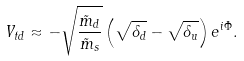Convert formula to latex. <formula><loc_0><loc_0><loc_500><loc_500>V _ { t d } \approx - \sqrt { \frac { \tilde { m } _ { d } } { \tilde { m } _ { s } } } \left ( \sqrt { \delta _ { d } } - \sqrt { \delta _ { u } } \right ) e ^ { i \Phi } .</formula> 